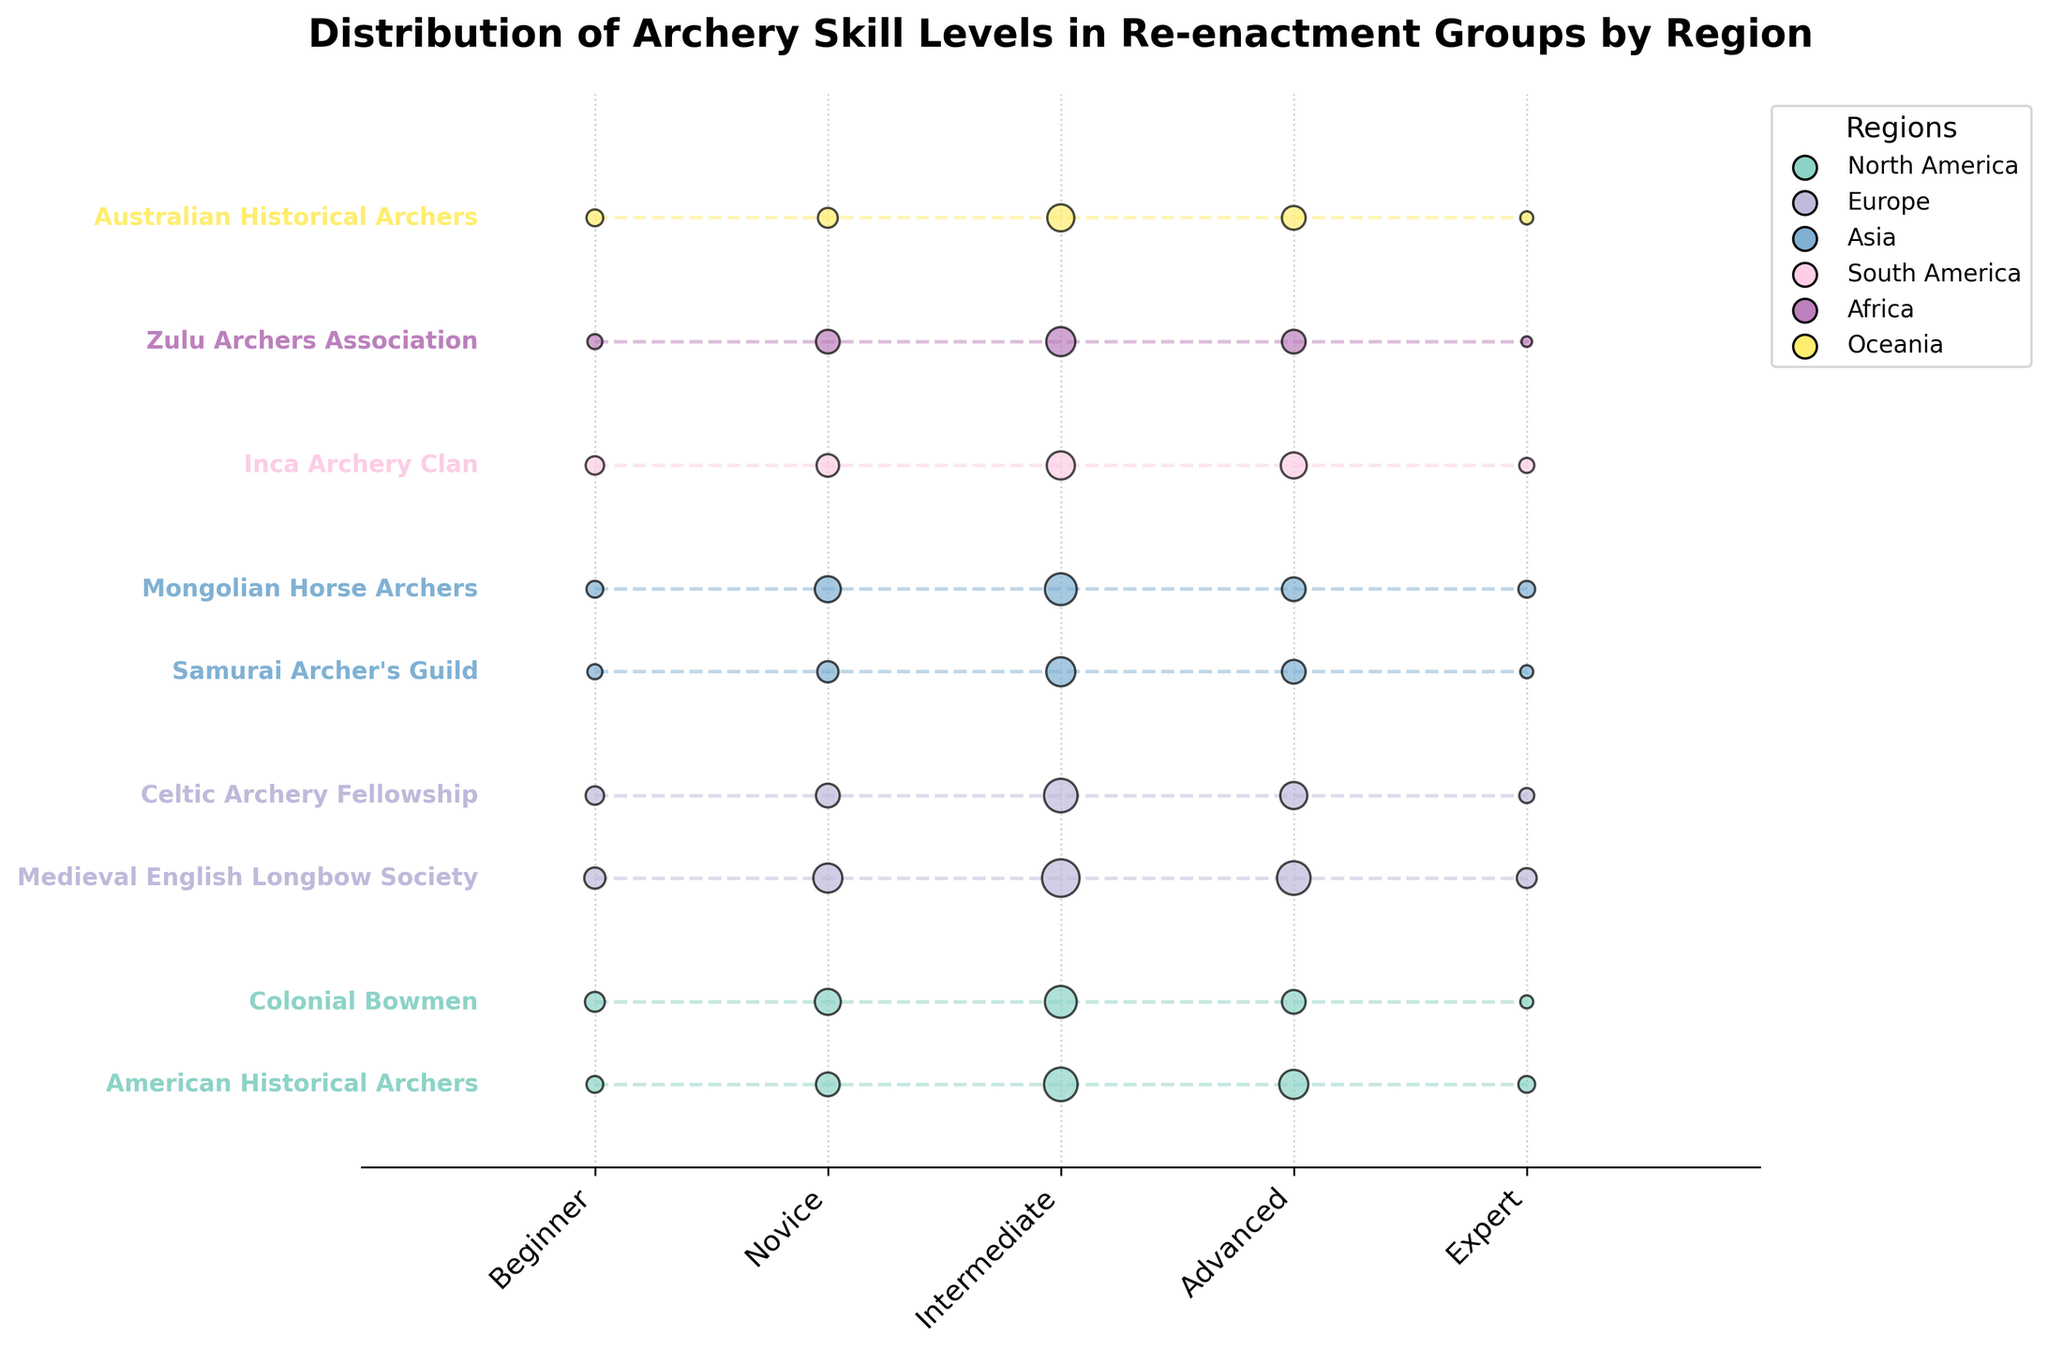How many skill levels are shown on the x-axis? The x-axis has labels indicating different skill levels. Simply count the number of labels presented. There are 5 skill levels: Beginner, Novice, Intermediate, Advanced, and Expert.
Answer: 5 What is the title of the plot? The title is typically located at the top of the plot, clearly stated. Read the text at the top of the plot. The title is "Distribution of Archery Skill Levels in Re-enactment Groups by Region".
Answer: Distribution of Archery Skill Levels in Re-enactment Groups by Region Which region has the group with the highest number of Intermediate skill level archers? Observe the plot to find the highest dot in the Intermediate skill level column (x=2) and check the group label on the y-axis. The Medieval English Longbow Society, located in Europe, has the highest number of Intermediate archers.
Answer: Europe What is the total number of Expert level archers in North America? Identify the groups within the North America region and sum their values for the Expert skill level. The groups are American Historical Archers (5) and Colonial Bowmen (3). Sum: 5 + 3 = 8.
Answer: 8 Which group in Asia has a higher number of Advanced skill level archers, Samurai Archer's Guild or Mongolian Horse Archers? Compare the y-position values for the Advanced skill level (x=3) for both groups in the Asia region. The Samurai Archer's Guild has 10 Advanced archers, while Mongolian Horse Archers also have 10.
Answer: They are equal How do the skill levels of Australian Historical Archers compare to those of Zulu Archers Association? Analyze the skill level values for both groups and compare each category. Australian Historical Archers: Beginner (5), Novice (7), Intermediate (13), Advanced (10), Expert (3). Zulu Archers Association: Beginner (4), Novice (10), Intermediate (15), Advanced (10), Expert (2). Australian Historical Archers have slightly more Beginners, have fewer Novices, Intermediates, the same number of Advanced, and more Experts than Zulu Archers Association.
Answer: Australian Historical Archers have slightly more Beginners and Experts, fewer Novices and Intermediates, and the same number of Advanced archers compared to Zulu Archers Association What is the ratio of Novice to Beginner archers in the Celtic Archery Fellowship? Find the values for Novice and Beginner in the Celtic Archery Fellowship and calculate the ratio by dividing the number of Novices by the number of Beginners. Novice (10) / Beginner (6) = 10/6 = 5/3.
Answer: 5/3 Which region has the fewest total number of Beginner archers? Add up the number of Beginner archers for each group in every region and identify the region with the smallest sum. North America: 5 + 7 = 12, Europe: 8 + 6 = 14, Asia: 4 + 5 = 9, South America: 6, Africa: 4, Oceania: 5. The fewest is in Africa.
Answer: Africa 